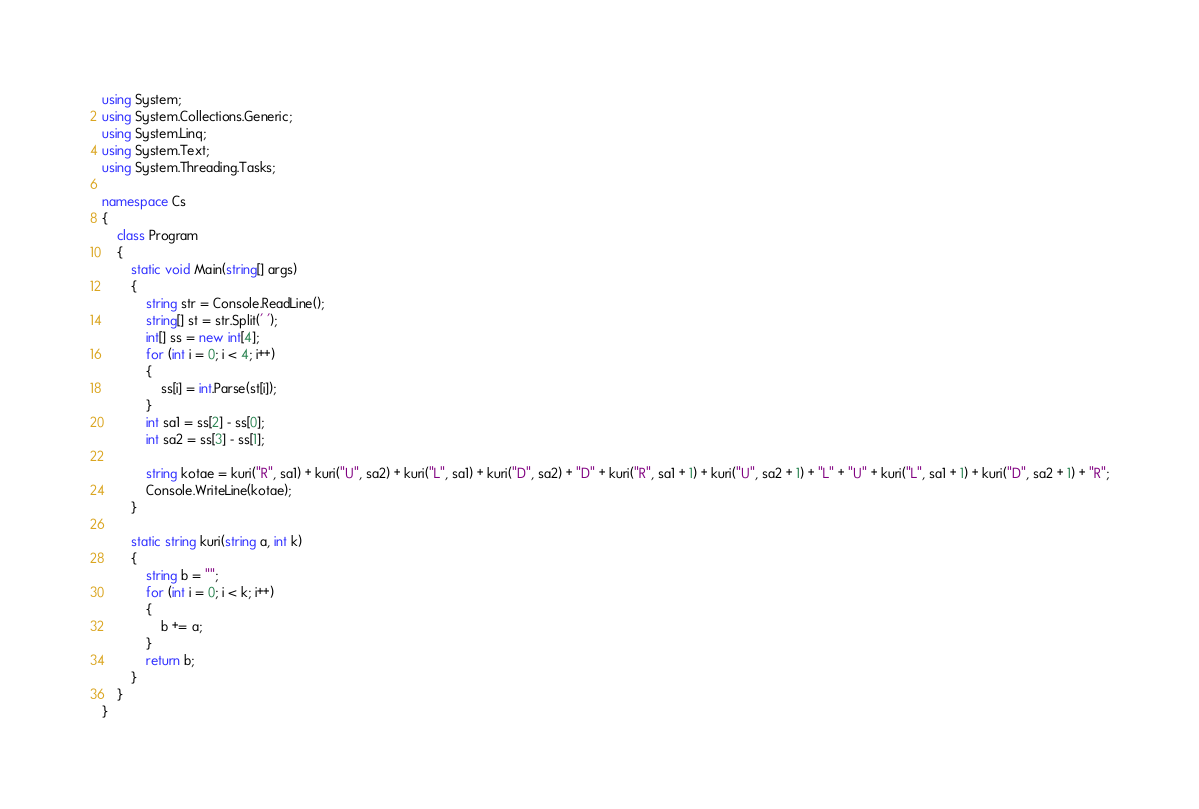<code> <loc_0><loc_0><loc_500><loc_500><_C#_>using System;
using System.Collections.Generic;
using System.Linq;
using System.Text;
using System.Threading.Tasks;

namespace Cs
{
    class Program
    {
        static void Main(string[] args)
        {
            string str = Console.ReadLine();
            string[] st = str.Split(' ');
            int[] ss = new int[4];
            for (int i = 0; i < 4; i++)
            {
                ss[i] = int.Parse(st[i]);
            }
            int sa1 = ss[2] - ss[0];
            int sa2 = ss[3] - ss[1];

            string kotae = kuri("R", sa1) + kuri("U", sa2) + kuri("L", sa1) + kuri("D", sa2) + "D" + kuri("R", sa1 + 1) + kuri("U", sa2 + 1) + "L" + "U" + kuri("L", sa1 + 1) + kuri("D", sa2 + 1) + "R";
            Console.WriteLine(kotae);
        }

        static string kuri(string a, int k)
        {
            string b = "";
            for (int i = 0; i < k; i++)
            {
                b += a;
            }
            return b;
        }
    }
}
</code> 